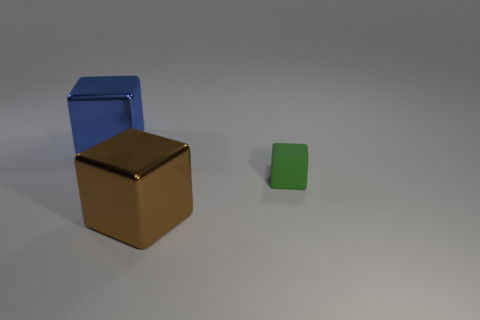Add 2 large blue things. How many objects exist? 5 Add 3 small matte things. How many small matte things are left? 4 Add 3 big blue rubber blocks. How many big blue rubber blocks exist? 3 Subtract 0 green balls. How many objects are left? 3 Subtract all blue shiny blocks. Subtract all small cyan shiny cubes. How many objects are left? 2 